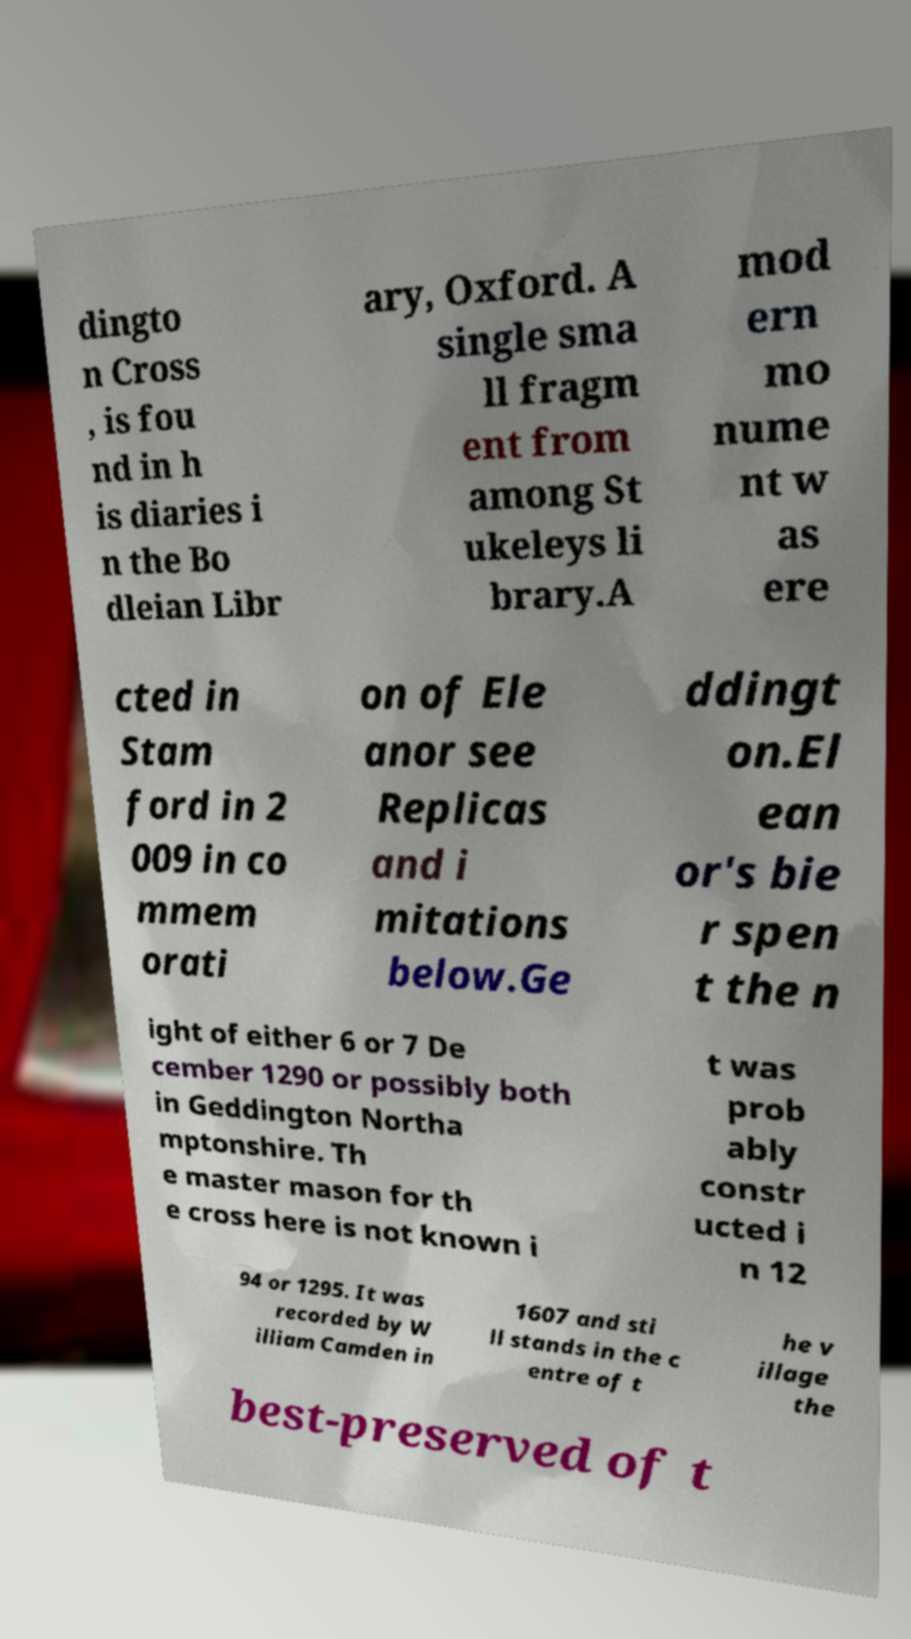I need the written content from this picture converted into text. Can you do that? dingto n Cross , is fou nd in h is diaries i n the Bo dleian Libr ary, Oxford. A single sma ll fragm ent from among St ukeleys li brary.A mod ern mo nume nt w as ere cted in Stam ford in 2 009 in co mmem orati on of Ele anor see Replicas and i mitations below.Ge ddingt on.El ean or's bie r spen t the n ight of either 6 or 7 De cember 1290 or possibly both in Geddington Northa mptonshire. Th e master mason for th e cross here is not known i t was prob ably constr ucted i n 12 94 or 1295. It was recorded by W illiam Camden in 1607 and sti ll stands in the c entre of t he v illage the best-preserved of t 